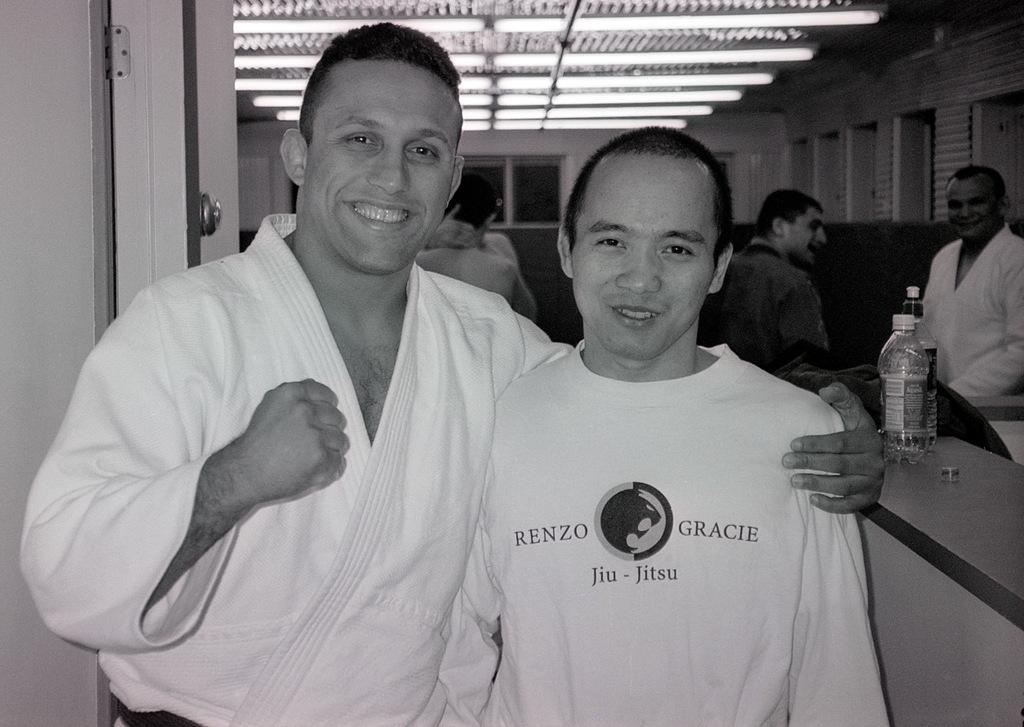Who is the main subject in the image? There is a boy in the image. What is the boy doing in the image? The boy is posing for the camera. Are there any other people in the image besides the boy? Yes, there is a karate player and other people visible in the image. What is the karate player doing in the image? The karate player is posing for the camera. What type of dinner is being served in the image? There is no dinner present in the image; it features a boy, a karate player, and other people posing for the camera. How does the twist in the image affect the overall composition? There is no twist mentioned in the image; it is a straightforward scene of people posing for the camera. 